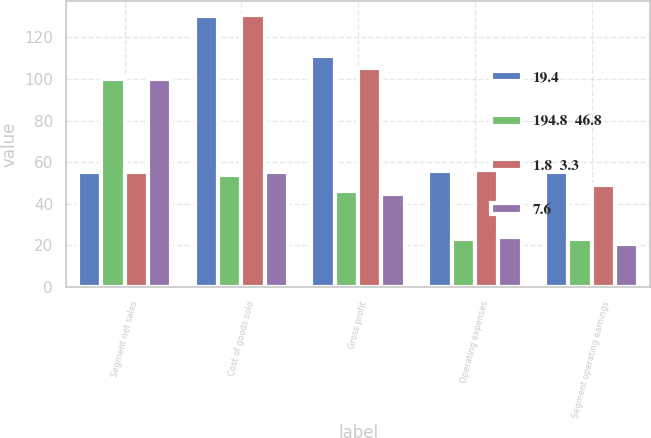<chart> <loc_0><loc_0><loc_500><loc_500><stacked_bar_chart><ecel><fcel>Segment net sales<fcel>Cost of goods sold<fcel>Gross profit<fcel>Operating expenses<fcel>Segment operating earnings<nl><fcel>19.4<fcel>55.4<fcel>130.4<fcel>111.2<fcel>55.8<fcel>55.4<nl><fcel>194.8  46.8<fcel>100<fcel>54<fcel>46<fcel>23.1<fcel>22.9<nl><fcel>1.8  3.3<fcel>55.4<fcel>131<fcel>105.5<fcel>56.3<fcel>49.2<nl><fcel>7.6<fcel>100<fcel>55.4<fcel>44.6<fcel>23.8<fcel>20.8<nl></chart> 